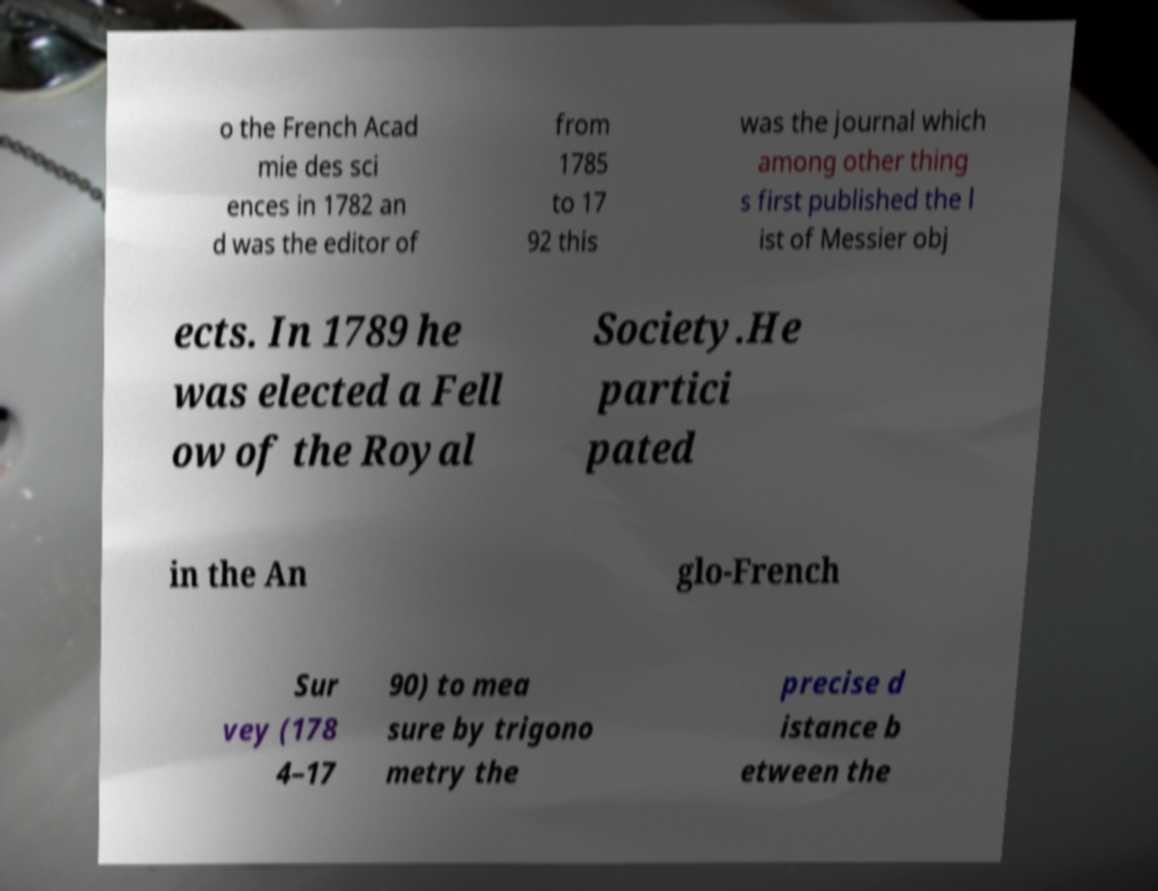For documentation purposes, I need the text within this image transcribed. Could you provide that? o the French Acad mie des sci ences in 1782 an d was the editor of from 1785 to 17 92 this was the journal which among other thing s first published the l ist of Messier obj ects. In 1789 he was elected a Fell ow of the Royal Society.He partici pated in the An glo-French Sur vey (178 4–17 90) to mea sure by trigono metry the precise d istance b etween the 